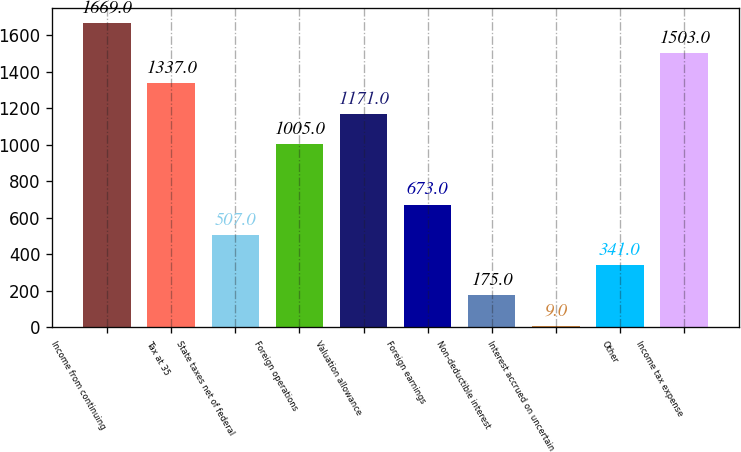<chart> <loc_0><loc_0><loc_500><loc_500><bar_chart><fcel>Income from continuing<fcel>Tax at 35<fcel>State taxes net of federal<fcel>Foreign operations<fcel>Valuation allowance<fcel>Foreign earnings<fcel>Non-deductible interest<fcel>Interest accrued on uncertain<fcel>Other<fcel>Income tax expense<nl><fcel>1669<fcel>1337<fcel>507<fcel>1005<fcel>1171<fcel>673<fcel>175<fcel>9<fcel>341<fcel>1503<nl></chart> 